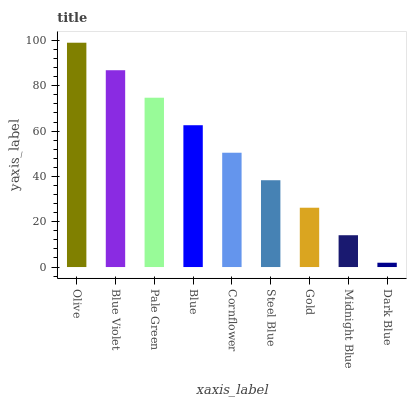Is Dark Blue the minimum?
Answer yes or no. Yes. Is Olive the maximum?
Answer yes or no. Yes. Is Blue Violet the minimum?
Answer yes or no. No. Is Blue Violet the maximum?
Answer yes or no. No. Is Olive greater than Blue Violet?
Answer yes or no. Yes. Is Blue Violet less than Olive?
Answer yes or no. Yes. Is Blue Violet greater than Olive?
Answer yes or no. No. Is Olive less than Blue Violet?
Answer yes or no. No. Is Cornflower the high median?
Answer yes or no. Yes. Is Cornflower the low median?
Answer yes or no. Yes. Is Olive the high median?
Answer yes or no. No. Is Blue Violet the low median?
Answer yes or no. No. 